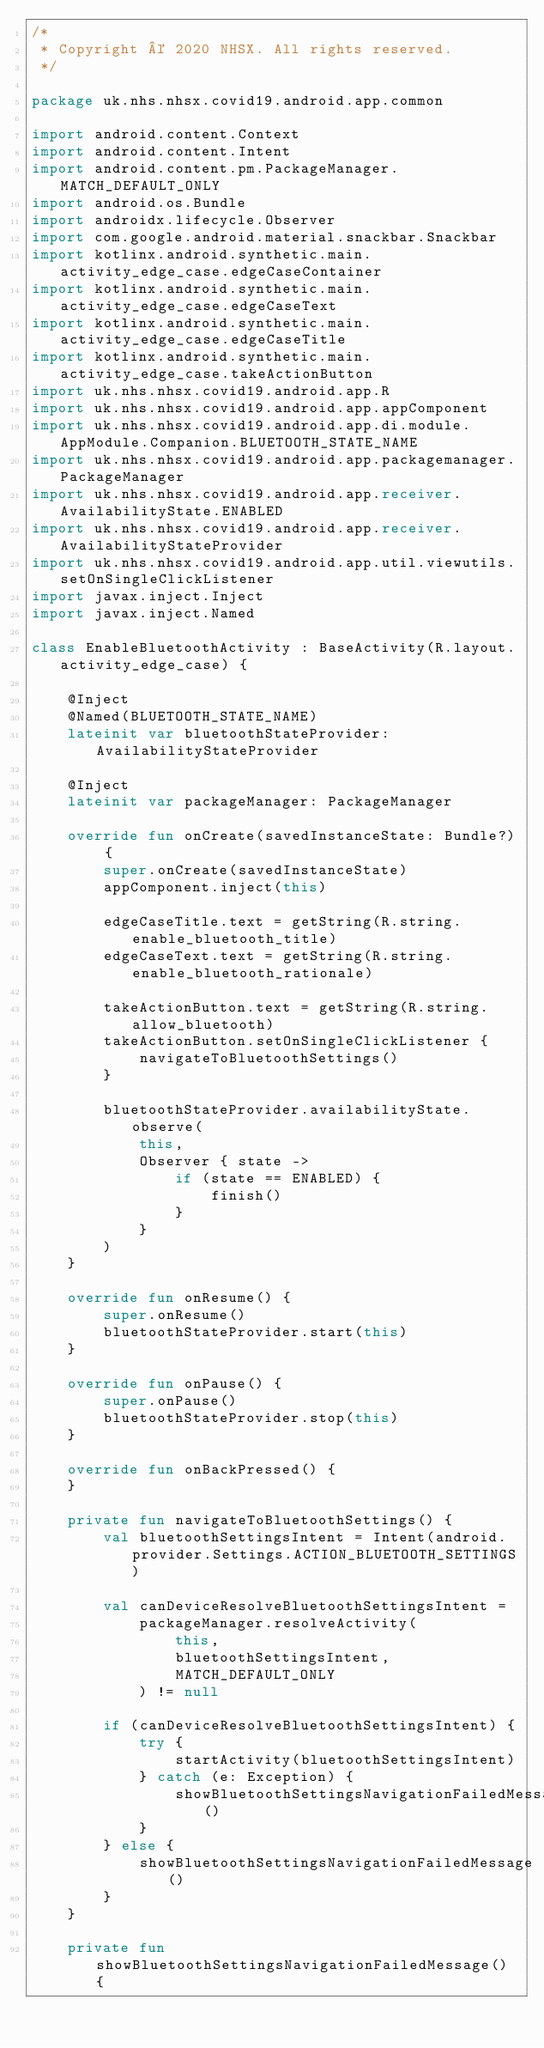<code> <loc_0><loc_0><loc_500><loc_500><_Kotlin_>/*
 * Copyright © 2020 NHSX. All rights reserved.
 */

package uk.nhs.nhsx.covid19.android.app.common

import android.content.Context
import android.content.Intent
import android.content.pm.PackageManager.MATCH_DEFAULT_ONLY
import android.os.Bundle
import androidx.lifecycle.Observer
import com.google.android.material.snackbar.Snackbar
import kotlinx.android.synthetic.main.activity_edge_case.edgeCaseContainer
import kotlinx.android.synthetic.main.activity_edge_case.edgeCaseText
import kotlinx.android.synthetic.main.activity_edge_case.edgeCaseTitle
import kotlinx.android.synthetic.main.activity_edge_case.takeActionButton
import uk.nhs.nhsx.covid19.android.app.R
import uk.nhs.nhsx.covid19.android.app.appComponent
import uk.nhs.nhsx.covid19.android.app.di.module.AppModule.Companion.BLUETOOTH_STATE_NAME
import uk.nhs.nhsx.covid19.android.app.packagemanager.PackageManager
import uk.nhs.nhsx.covid19.android.app.receiver.AvailabilityState.ENABLED
import uk.nhs.nhsx.covid19.android.app.receiver.AvailabilityStateProvider
import uk.nhs.nhsx.covid19.android.app.util.viewutils.setOnSingleClickListener
import javax.inject.Inject
import javax.inject.Named

class EnableBluetoothActivity : BaseActivity(R.layout.activity_edge_case) {

    @Inject
    @Named(BLUETOOTH_STATE_NAME)
    lateinit var bluetoothStateProvider: AvailabilityStateProvider

    @Inject
    lateinit var packageManager: PackageManager

    override fun onCreate(savedInstanceState: Bundle?) {
        super.onCreate(savedInstanceState)
        appComponent.inject(this)

        edgeCaseTitle.text = getString(R.string.enable_bluetooth_title)
        edgeCaseText.text = getString(R.string.enable_bluetooth_rationale)

        takeActionButton.text = getString(R.string.allow_bluetooth)
        takeActionButton.setOnSingleClickListener {
            navigateToBluetoothSettings()
        }

        bluetoothStateProvider.availabilityState.observe(
            this,
            Observer { state ->
                if (state == ENABLED) {
                    finish()
                }
            }
        )
    }

    override fun onResume() {
        super.onResume()
        bluetoothStateProvider.start(this)
    }

    override fun onPause() {
        super.onPause()
        bluetoothStateProvider.stop(this)
    }

    override fun onBackPressed() {
    }

    private fun navigateToBluetoothSettings() {
        val bluetoothSettingsIntent = Intent(android.provider.Settings.ACTION_BLUETOOTH_SETTINGS)

        val canDeviceResolveBluetoothSettingsIntent =
            packageManager.resolveActivity(
                this,
                bluetoothSettingsIntent,
                MATCH_DEFAULT_ONLY
            ) != null

        if (canDeviceResolveBluetoothSettingsIntent) {
            try {
                startActivity(bluetoothSettingsIntent)
            } catch (e: Exception) {
                showBluetoothSettingsNavigationFailedMessage()
            }
        } else {
            showBluetoothSettingsNavigationFailedMessage()
        }
    }

    private fun showBluetoothSettingsNavigationFailedMessage() {</code> 